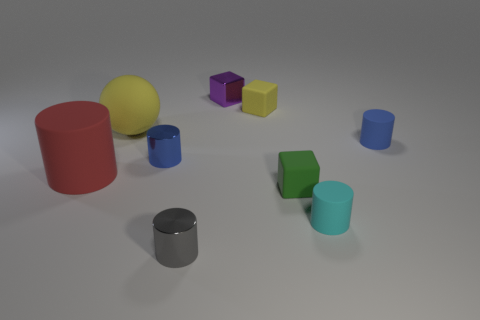What is the texture of the objects in the image? The objects in the image have a smooth and even matte texture, which diffusely reflects light without shine or glossiness. 